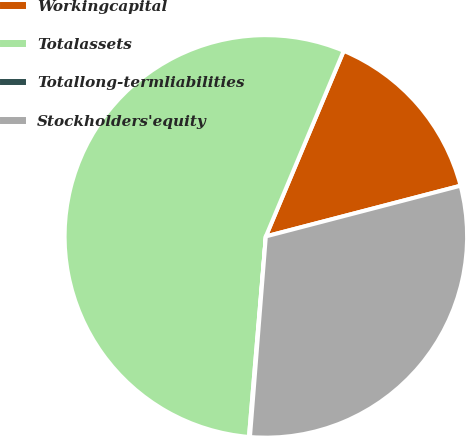Convert chart to OTSL. <chart><loc_0><loc_0><loc_500><loc_500><pie_chart><fcel>Workingcapital<fcel>Totalassets<fcel>Totallong-termliabilities<fcel>Stockholders'equity<nl><fcel>14.62%<fcel>54.98%<fcel>0.08%<fcel>30.31%<nl></chart> 